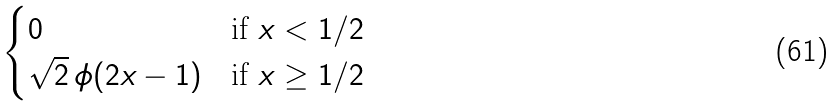<formula> <loc_0><loc_0><loc_500><loc_500>\begin{cases} 0 & \text {if $x<1/2$} \\ \sqrt { 2 } \, \phi ( 2 x - 1 ) & \text {if $x\geq 1/2$} \end{cases}</formula> 